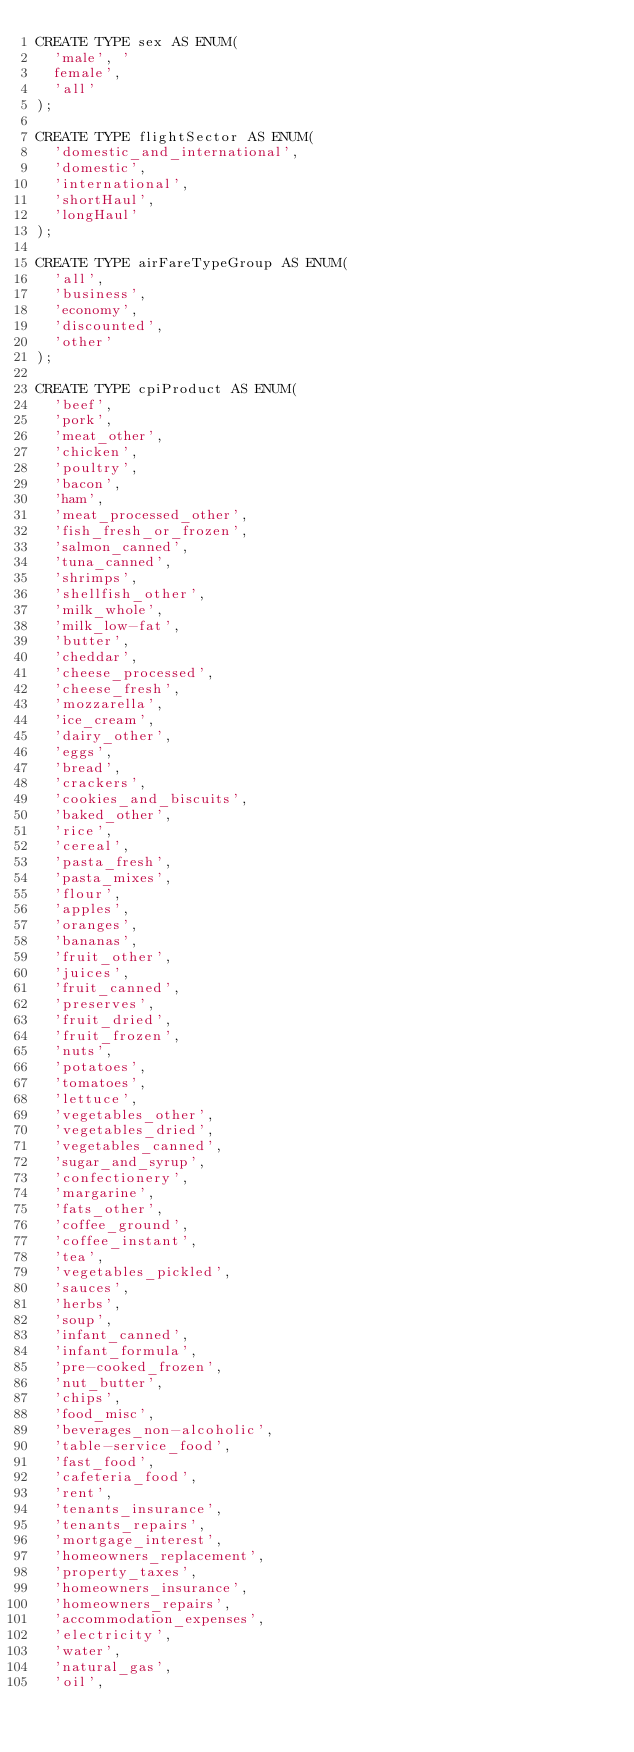Convert code to text. <code><loc_0><loc_0><loc_500><loc_500><_SQL_>CREATE TYPE sex AS ENUM(
  'male', '
  female',
  'all'
);

CREATE TYPE flightSector AS ENUM(
  'domestic_and_international',
  'domestic',
  'international',
  'shortHaul',
  'longHaul'
);

CREATE TYPE airFareTypeGroup AS ENUM(
  'all',
  'business',
  'economy',
  'discounted',
  'other'
);

CREATE TYPE cpiProduct AS ENUM(
  'beef',
  'pork',
  'meat_other',
  'chicken',
  'poultry',
  'bacon',
  'ham',
  'meat_processed_other',
  'fish_fresh_or_frozen',
  'salmon_canned',
  'tuna_canned',
  'shrimps',
  'shellfish_other',
  'milk_whole',
  'milk_low-fat',
  'butter',
  'cheddar',
  'cheese_processed',
  'cheese_fresh',
  'mozzarella',
  'ice_cream',
  'dairy_other',
  'eggs',
  'bread',
  'crackers',
  'cookies_and_biscuits',
  'baked_other',
  'rice',
  'cereal',
  'pasta_fresh',
  'pasta_mixes',
  'flour',
  'apples',
  'oranges',
  'bananas',
  'fruit_other',
  'juices',
  'fruit_canned',
  'preserves',
  'fruit_dried',
  'fruit_frozen',
  'nuts',
  'potatoes',
  'tomatoes',
  'lettuce',
  'vegetables_other',
  'vegetables_dried',
  'vegetables_canned',
  'sugar_and_syrup',
  'confectionery',
  'margarine',
  'fats_other',
  'coffee_ground',
  'coffee_instant',
  'tea',
  'vegetables_pickled',
  'sauces',
  'herbs',
  'soup',
  'infant_canned',
  'infant_formula',
  'pre-cooked_frozen',
  'nut_butter',
  'chips',
  'food_misc',
  'beverages_non-alcoholic',
  'table-service_food',
  'fast_food',
  'cafeteria_food',
  'rent',
  'tenants_insurance',
  'tenants_repairs',
  'mortgage_interest',
  'homeowners_replacement',
  'property_taxes',
  'homeowners_insurance',
  'homeowners_repairs',
  'accommodation_expenses',
  'electricity',
  'water',
  'natural_gas',
  'oil',</code> 